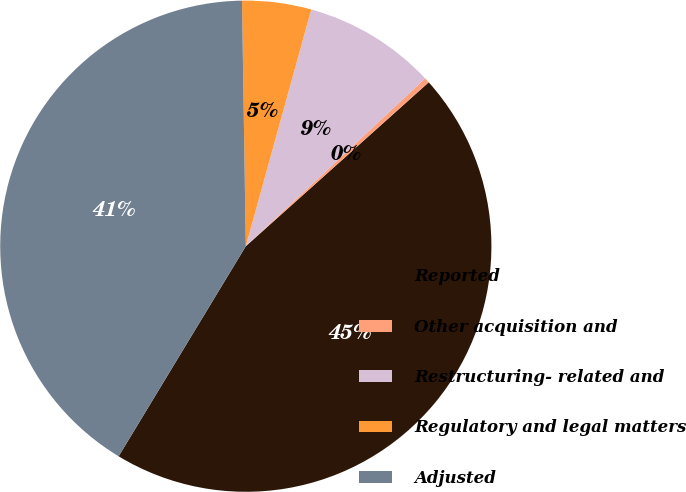<chart> <loc_0><loc_0><loc_500><loc_500><pie_chart><fcel>Reported<fcel>Other acquisition and<fcel>Restructuring- related and<fcel>Regulatory and legal matters<fcel>Adjusted<nl><fcel>45.29%<fcel>0.35%<fcel>8.73%<fcel>4.54%<fcel>41.09%<nl></chart> 